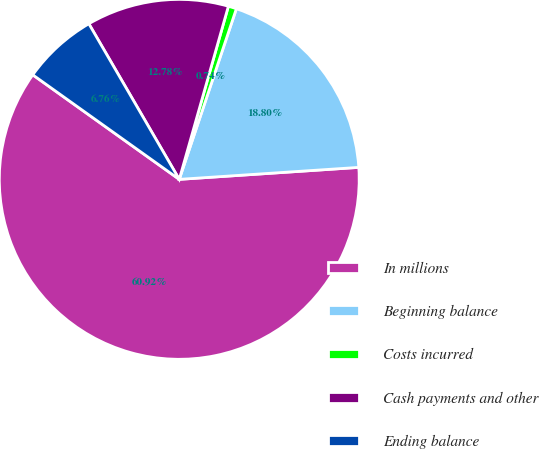Convert chart. <chart><loc_0><loc_0><loc_500><loc_500><pie_chart><fcel>In millions<fcel>Beginning balance<fcel>Costs incurred<fcel>Cash payments and other<fcel>Ending balance<nl><fcel>60.93%<fcel>18.8%<fcel>0.74%<fcel>12.78%<fcel>6.76%<nl></chart> 